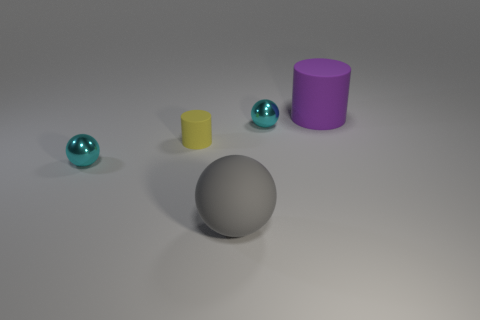Subtract all large gray rubber spheres. How many spheres are left? 2 Add 4 tiny metal things. How many objects exist? 9 Subtract all gray balls. How many balls are left? 2 Subtract all spheres. How many objects are left? 2 Subtract all cyan blocks. How many yellow spheres are left? 0 Add 3 small red spheres. How many small red spheres exist? 3 Subtract 0 brown cubes. How many objects are left? 5 Subtract 1 cylinders. How many cylinders are left? 1 Subtract all yellow cylinders. Subtract all purple spheres. How many cylinders are left? 1 Subtract all small cyan things. Subtract all small objects. How many objects are left? 0 